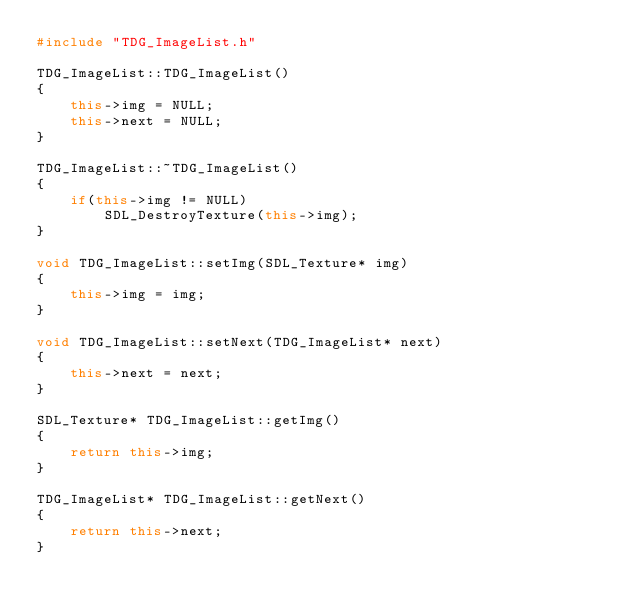Convert code to text. <code><loc_0><loc_0><loc_500><loc_500><_C++_>#include "TDG_ImageList.h"

TDG_ImageList::TDG_ImageList()
{
    this->img = NULL;
    this->next = NULL;
}

TDG_ImageList::~TDG_ImageList()
{
    if(this->img != NULL)
        SDL_DestroyTexture(this->img);
}

void TDG_ImageList::setImg(SDL_Texture* img)
{
    this->img = img;
}

void TDG_ImageList::setNext(TDG_ImageList* next)
{
    this->next = next;
}

SDL_Texture* TDG_ImageList::getImg()
{
    return this->img;
}

TDG_ImageList* TDG_ImageList::getNext()
{
    return this->next;
}
</code> 